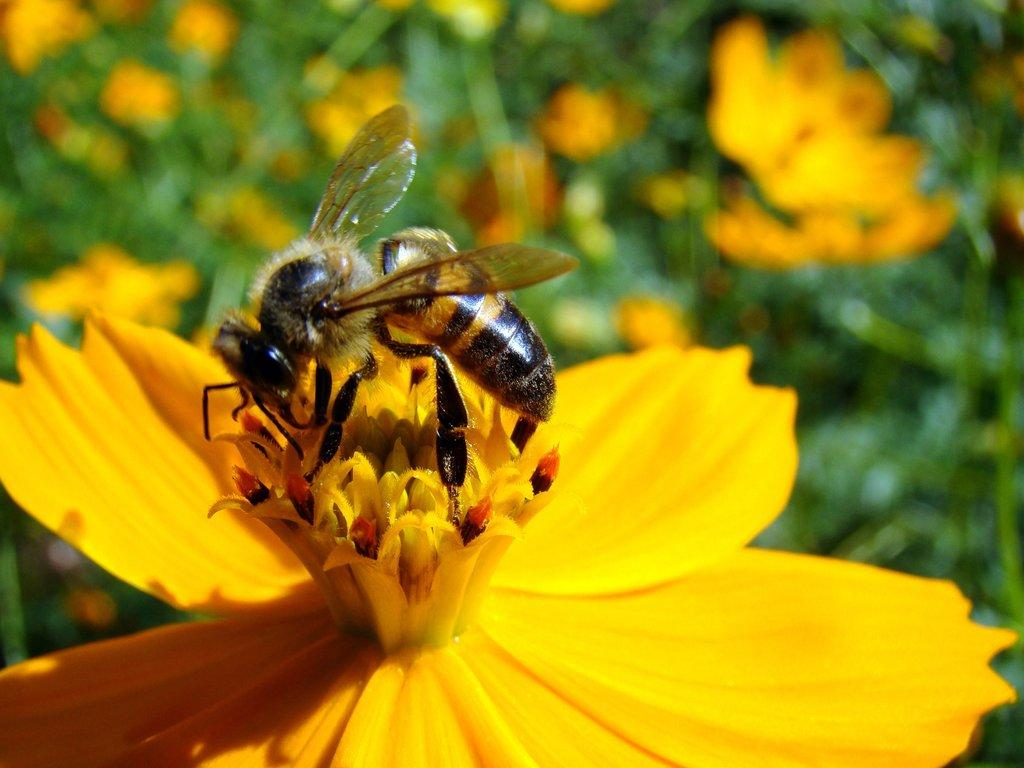What type of flower can be seen in the image? There is a yellow color flower in the image. Is there any other living creature present on the flower? Yes, there is a bee on the flower. What can be seen in the background of the image? There are flowers and leaves in the background of the image. What type of music can be heard playing in the background of the image? There is no music present in the image; it is a still photograph of a flower and a bee. 